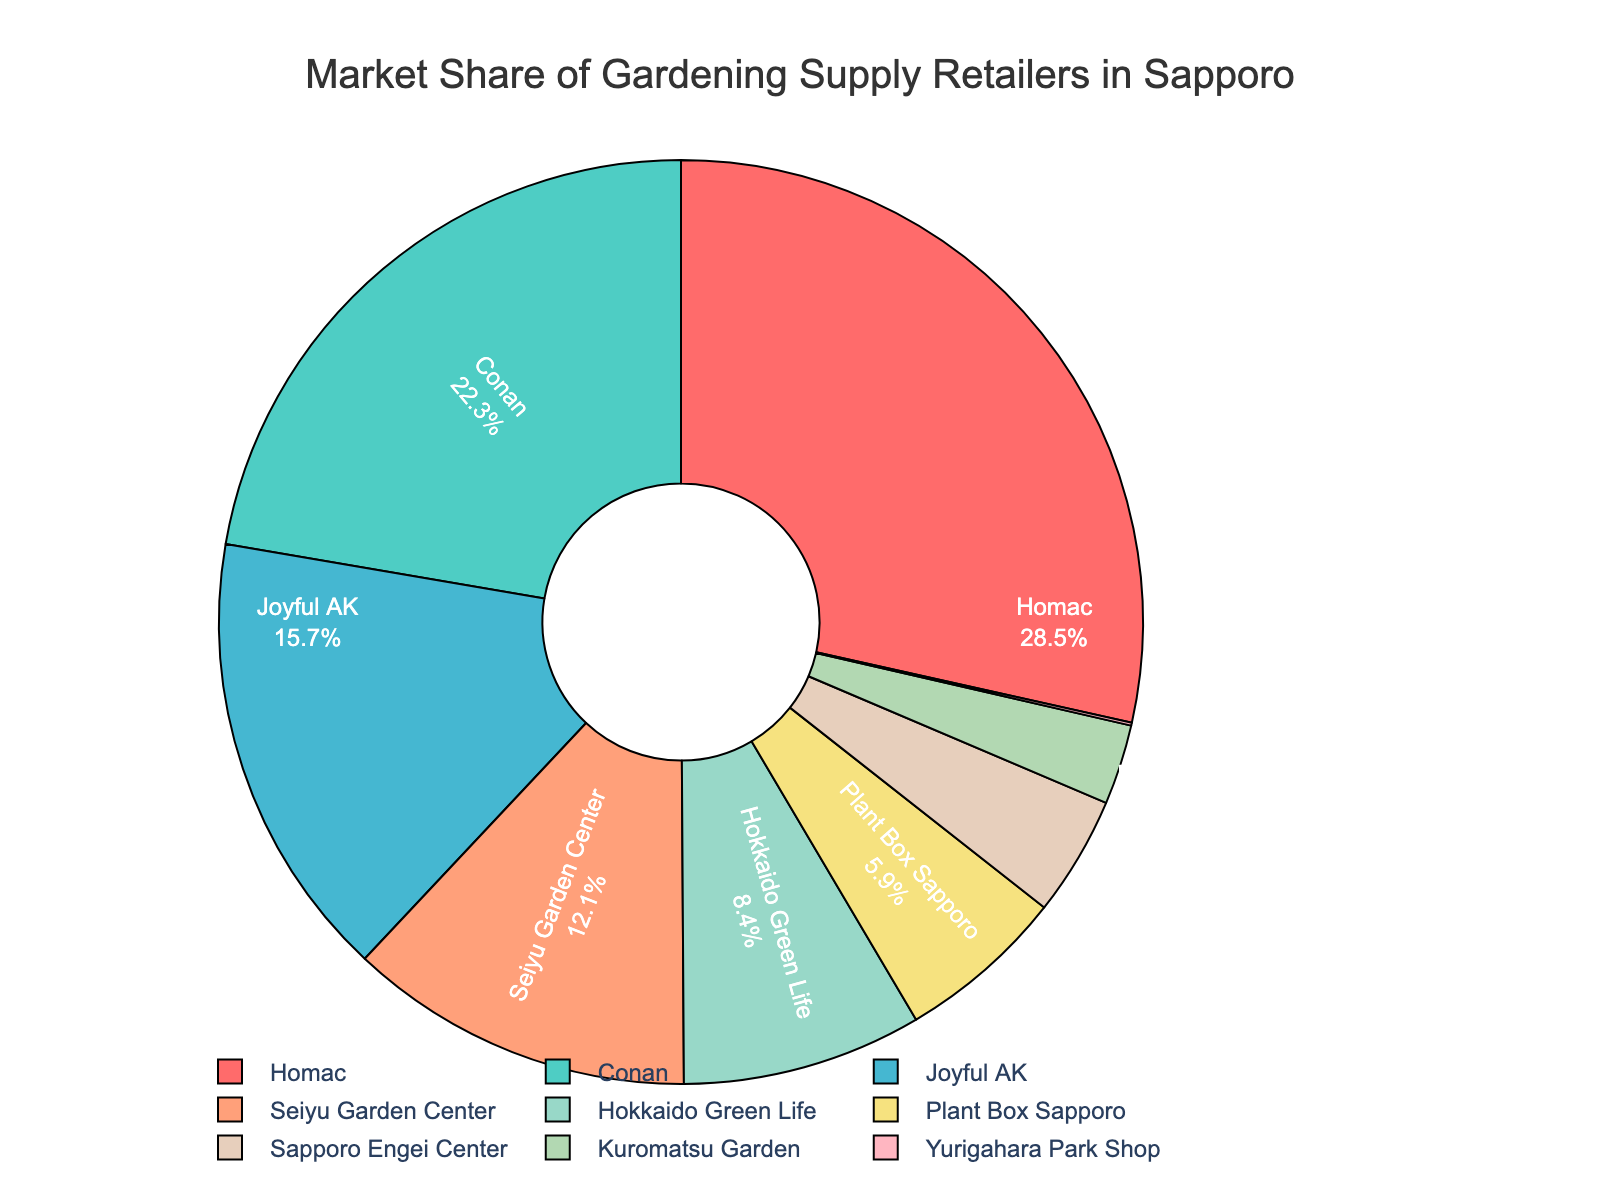What is the market share of the retailer with the second-highest market share? The retailer with the second-highest market share is Conan. The figure shows Conan's market share as 22.3%.
Answer: 22.3% Which retailers have less than 10% market share? The retailers with less than 10% market share are Hokkaido Green Life, Plant Box Sapporo, Sapporo Engei Center, Kuromatsu Garden, and Yurigahara Park Shop.
Answer: Hokkaido Green Life, Plant Box Sapporo, Sapporo Engei Center, Kuromatsu Garden, Yurigahara Park Shop What is the combined market share of Homac and Conan? Homac has a market share of 28.5% and Conan has a market share of 22.3%. Adding these together gives 28.5% + 22.3% = 50.8%.
Answer: 50.8% Which retailer has the smallest market share, and what is it? The retailer with the smallest market share is Yurigahara Park Shop with a market share of 0.1%.
Answer: Yurigahara Park Shop, 0.1% What is the difference in market share between Joyful AK and Seiyu Garden Center? Joyful AK has a market share of 15.7% and Seiyu Garden Center has a market share of 12.1%. Subtracting these gives 15.7% - 12.1% = 3.6%.
Answer: 3.6% Name three retailers with market shares between 10% and 20%. The retailers with market shares between 10% and 20% are Joyful AK (15.7%) and Seiyu Garden Center (12.1%).
Answer: Joyful AK, Seiyu Garden Center Which retailer occupies the largest segment in the pie chart? The largest segment in the pie chart represents Homac, which has the largest market share of 28.5%.
Answer: Homac What percentage of the market share is accounted for by retailers with less than 5% each? Retailers with less than 5% market share are Sapporo Engei Center (4.2%), Kuromatsu Garden (2.8%), and Yurigahara Park Shop (0.1%). Adding these together gives 4.2% + 2.8% + 0.1% = 7.1%.
Answer: 7.1% Which segment in the pie chart is colored red? The segment colored red corresponds to Homac, the retailer with the largest market share at 28.5%.
Answer: Homac 